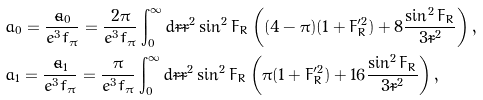<formula> <loc_0><loc_0><loc_500><loc_500>& a _ { 0 } = \frac { { \tilde { a } } _ { 0 } } { e ^ { 3 } f _ { \pi } } = \frac { 2 \pi } { e ^ { 3 } f _ { \pi } } \int ^ { \infty } _ { 0 } d \tilde { r } \tilde { r } ^ { 2 } \sin ^ { 2 } F _ { R } \left ( ( 4 - \pi ) ( 1 + F _ { R } ^ { \prime 2 } ) + 8 \frac { \sin ^ { 2 } F _ { R } } { 3 \tilde { r } ^ { 2 } } \right ) , \\ & a _ { 1 } = \frac { { \tilde { a } } _ { 1 } } { e ^ { 3 } f _ { \pi } } = \frac { \pi } { e ^ { 3 } f _ { \pi } } \int ^ { \infty } _ { 0 } d \tilde { r } \tilde { r } ^ { 2 } \sin ^ { 2 } F _ { R } \left ( \pi ( 1 + F _ { R } ^ { \prime 2 } ) + 1 6 \frac { \sin ^ { 2 } F _ { R } } { 3 \tilde { r } ^ { 2 } } \right ) ,</formula> 